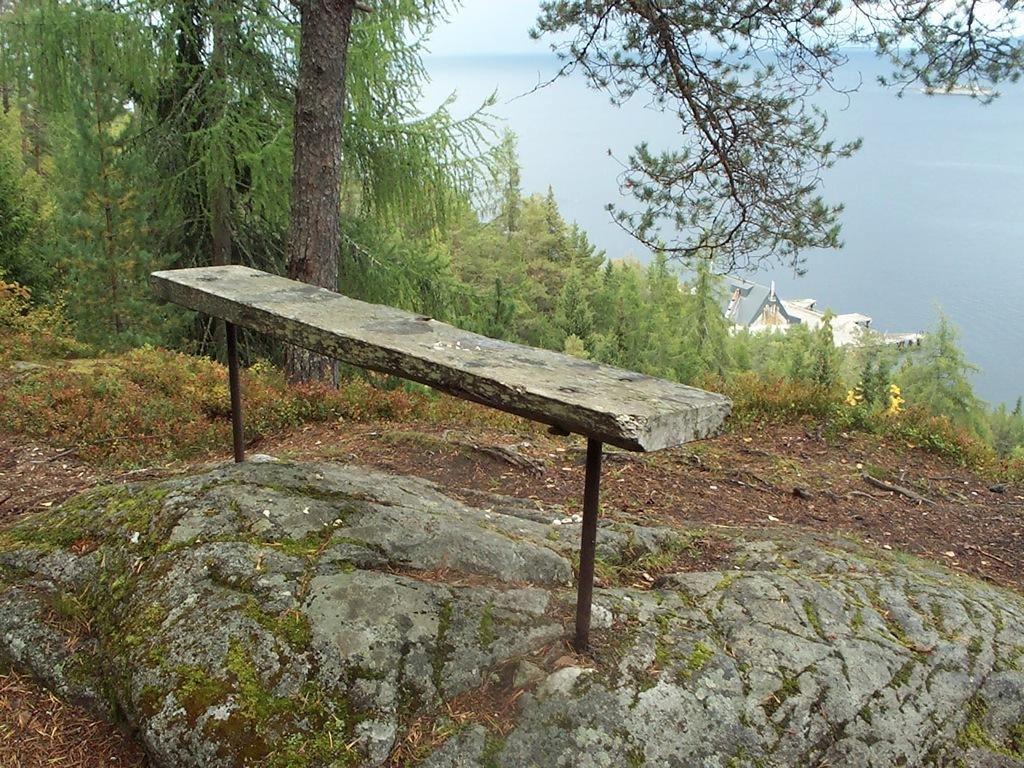What type of vegetation can be seen in the image? There are trees in the image. What type of structure is present in the image? There is a house in the image. What natural element is visible in the image? There is water visible in the image. What geological feature can be seen in the image? There is a rock in the image. What type of furniture is present in the image? There is a concrete table in the image. Can you tell me how many cacti are present in the image? There are no cacti present in the image; only trees are mentioned as vegetation. What type of learning activity is taking place in the image? There is no learning activity depicted in the image; it features trees, a house, water, a rock, and a concrete table. 